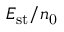Convert formula to latex. <formula><loc_0><loc_0><loc_500><loc_500>E _ { s t } / n _ { 0 }</formula> 